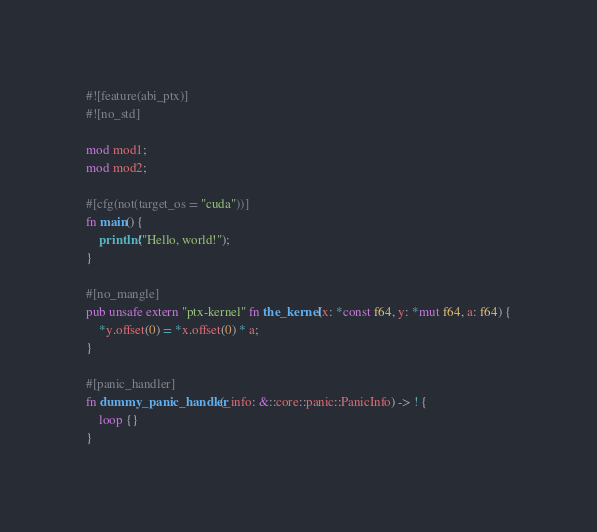Convert code to text. <code><loc_0><loc_0><loc_500><loc_500><_Rust_>#![feature(abi_ptx)]
#![no_std]

mod mod1;
mod mod2;

#[cfg(not(target_os = "cuda"))]
fn main() {
    println!("Hello, world!");
}

#[no_mangle]
pub unsafe extern "ptx-kernel" fn the_kernel(x: *const f64, y: *mut f64, a: f64) {
    *y.offset(0) = *x.offset(0) * a;
}

#[panic_handler]
fn dummy_panic_handler(_info: &::core::panic::PanicInfo) -> ! {
    loop {}
}
</code> 